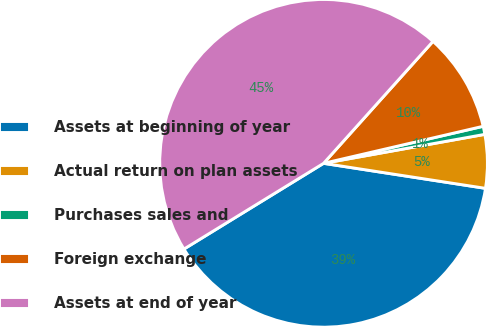<chart> <loc_0><loc_0><loc_500><loc_500><pie_chart><fcel>Assets at beginning of year<fcel>Actual return on plan assets<fcel>Purchases sales and<fcel>Foreign exchange<fcel>Assets at end of year<nl><fcel>38.8%<fcel>5.27%<fcel>0.8%<fcel>9.73%<fcel>45.41%<nl></chart> 